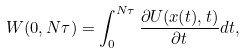<formula> <loc_0><loc_0><loc_500><loc_500>W ( 0 , N \tau ) = \int _ { 0 } ^ { N \tau } \frac { \partial U ( x ( t ) , t ) } { \partial t } d t ,</formula> 